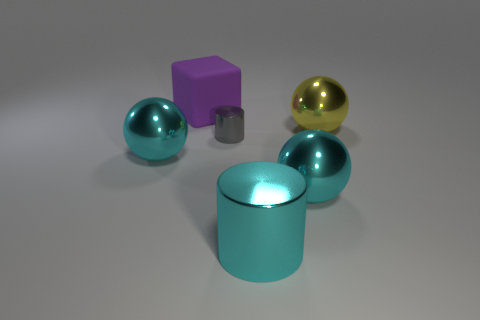What number of other objects are the same color as the block?
Ensure brevity in your answer.  0. What material is the thing that is behind the large yellow metallic thing that is behind the gray shiny cylinder?
Make the answer very short. Rubber. Is there a yellow shiny cube?
Provide a short and direct response. No. There is a cyan sphere that is in front of the cyan sphere on the left side of the large purple matte object; what size is it?
Provide a succinct answer. Large. Is the number of cyan spheres that are behind the big yellow ball greater than the number of large cyan things on the right side of the big block?
Provide a short and direct response. No. How many blocks are either shiny things or big yellow objects?
Offer a very short reply. 0. Are there any other things that are the same size as the purple rubber thing?
Offer a terse response. Yes. Do the yellow thing that is behind the gray object and the matte thing have the same shape?
Offer a very short reply. No. What is the color of the matte cube?
Offer a very short reply. Purple. The other metal thing that is the same shape as the tiny gray thing is what color?
Provide a short and direct response. Cyan. 